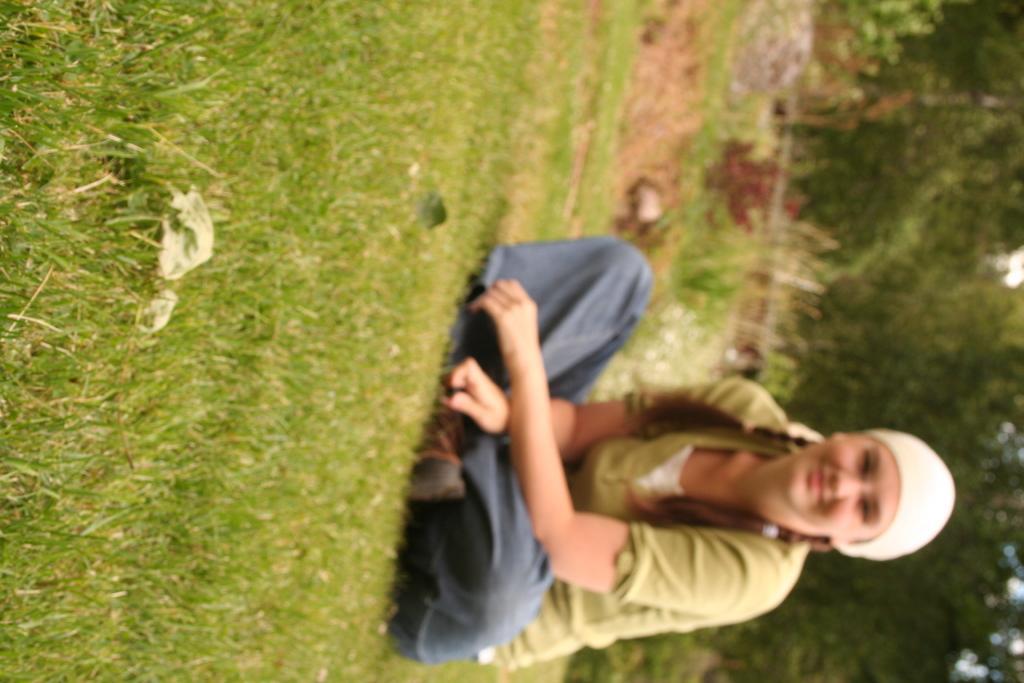Can you describe this image briefly? There is a girl sitting on the grassland in the foreground and greenery in the background area. 